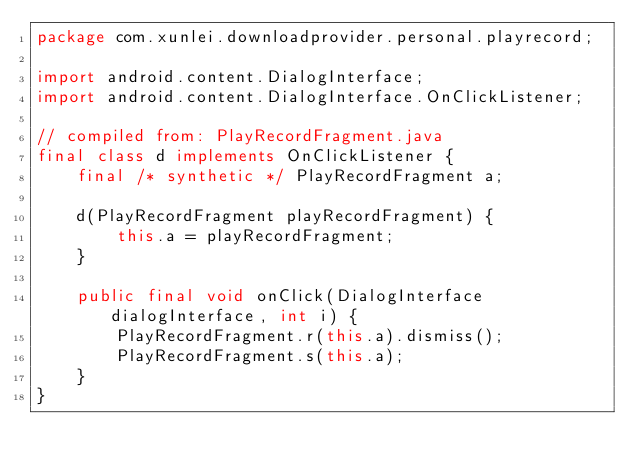<code> <loc_0><loc_0><loc_500><loc_500><_Java_>package com.xunlei.downloadprovider.personal.playrecord;

import android.content.DialogInterface;
import android.content.DialogInterface.OnClickListener;

// compiled from: PlayRecordFragment.java
final class d implements OnClickListener {
    final /* synthetic */ PlayRecordFragment a;

    d(PlayRecordFragment playRecordFragment) {
        this.a = playRecordFragment;
    }

    public final void onClick(DialogInterface dialogInterface, int i) {
        PlayRecordFragment.r(this.a).dismiss();
        PlayRecordFragment.s(this.a);
    }
}
</code> 